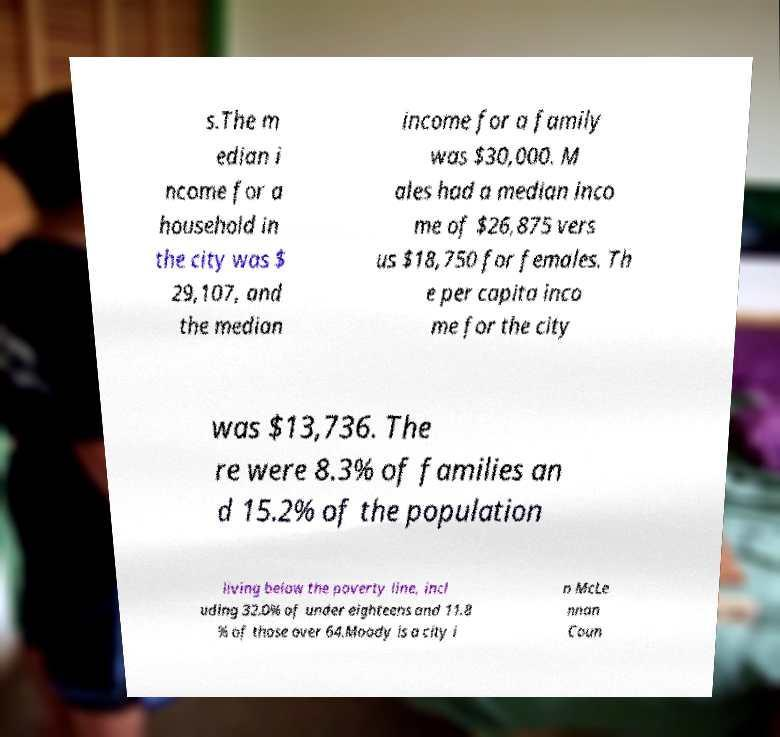Could you extract and type out the text from this image? s.The m edian i ncome for a household in the city was $ 29,107, and the median income for a family was $30,000. M ales had a median inco me of $26,875 vers us $18,750 for females. Th e per capita inco me for the city was $13,736. The re were 8.3% of families an d 15.2% of the population living below the poverty line, incl uding 32.0% of under eighteens and 11.8 % of those over 64.Moody is a city i n McLe nnan Coun 